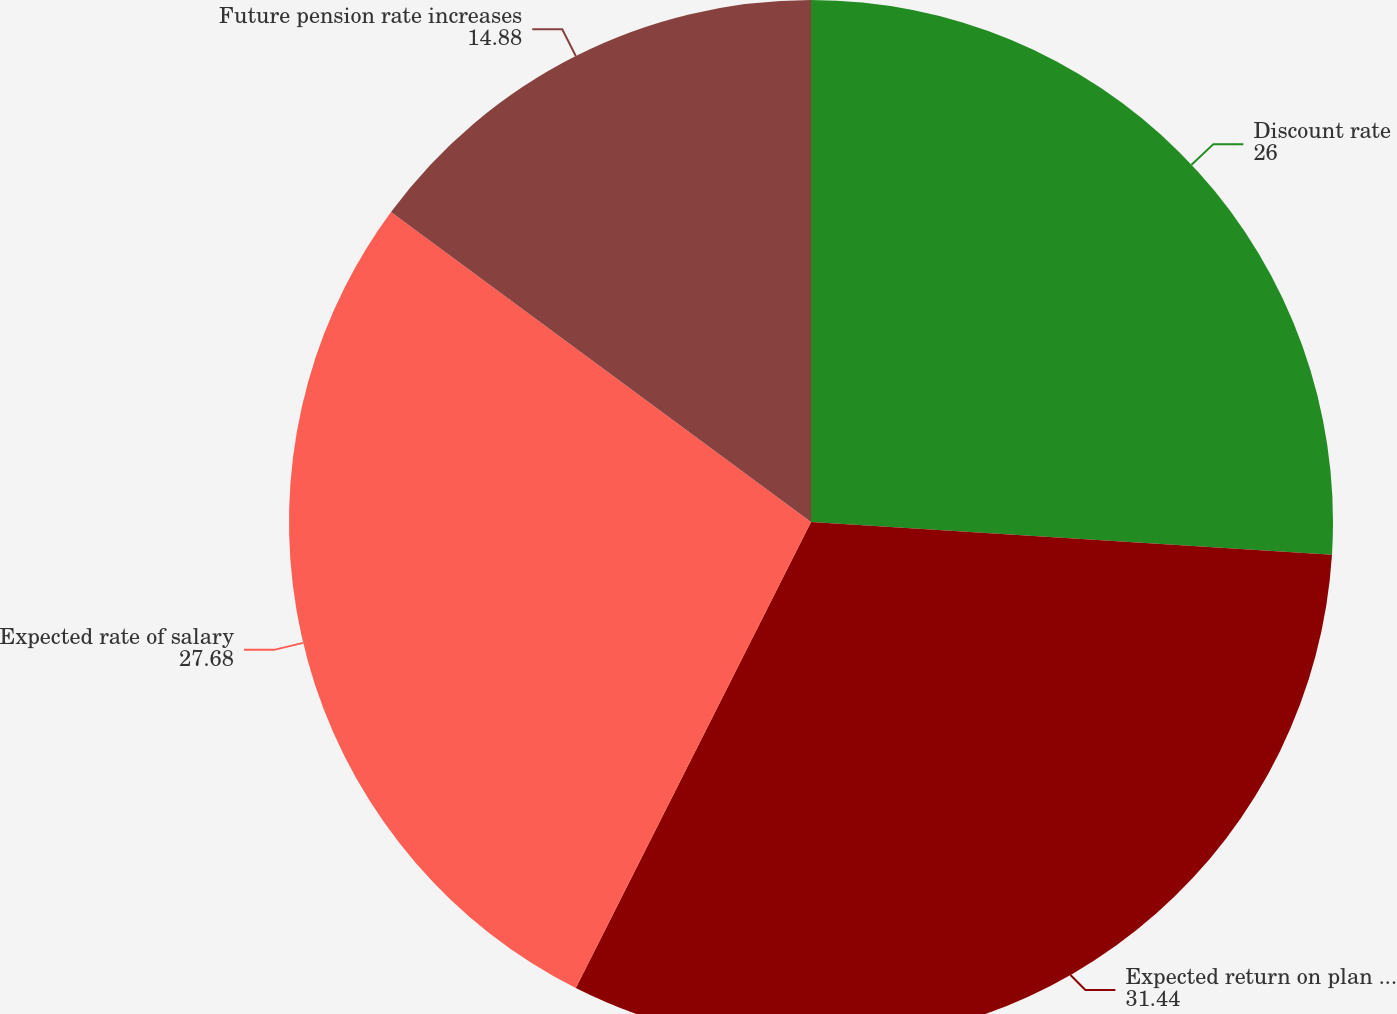<chart> <loc_0><loc_0><loc_500><loc_500><pie_chart><fcel>Discount rate<fcel>Expected return on plan assets<fcel>Expected rate of salary<fcel>Future pension rate increases<nl><fcel>26.0%<fcel>31.44%<fcel>27.68%<fcel>14.88%<nl></chart> 